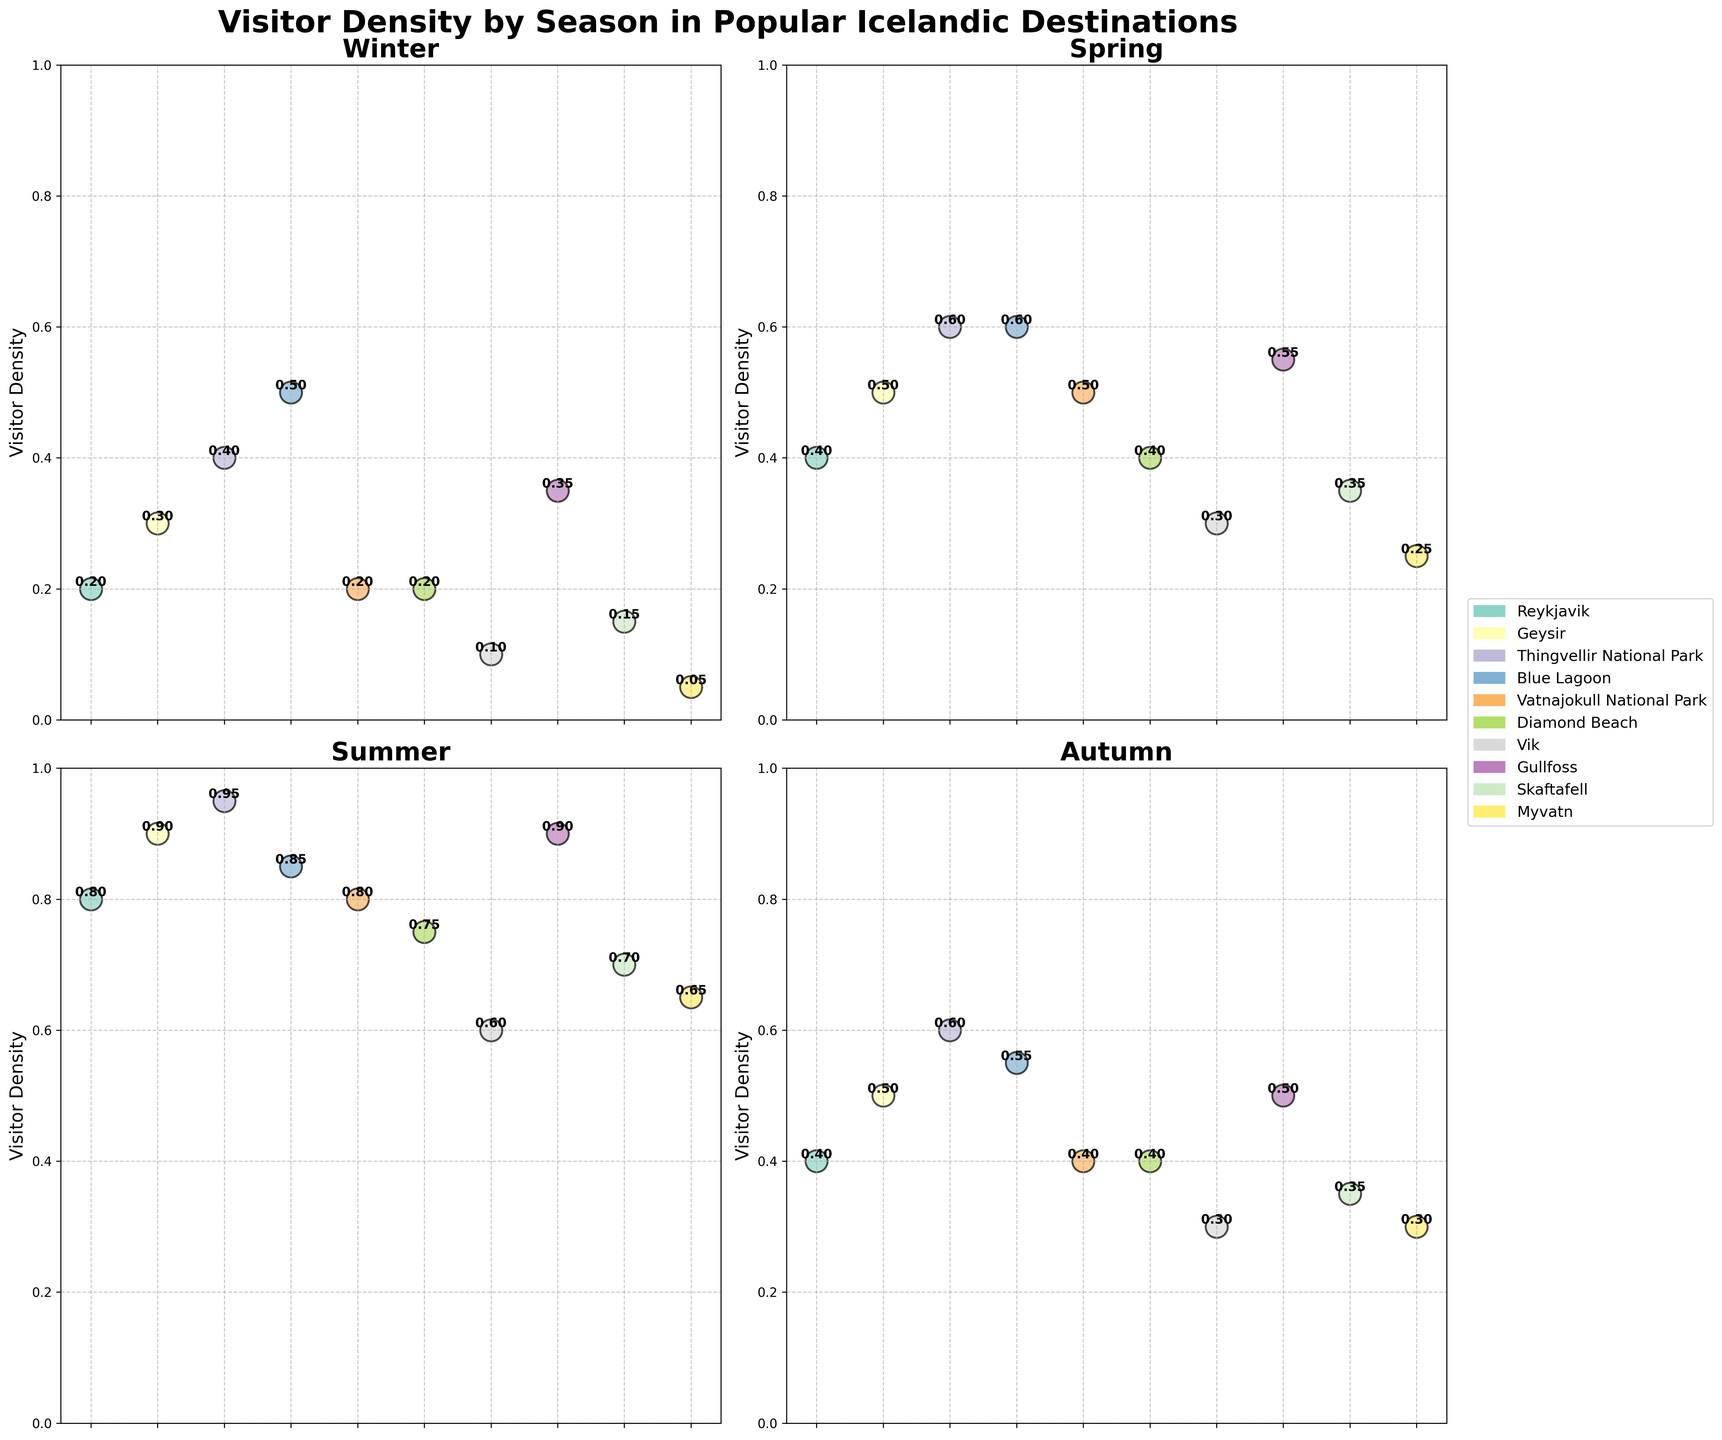What is the visitor density in Reykjavik during the summer? First, locate the subplot for summer. Within that subplot, look for the dot representing Reykjavik and read the visitor density value labeled next to it.
Answer: 0.8 Which season has the highest visitor density at Thingvellir National Park? Inspect each subplot for Thingvellir National Park and note the visitor densities. Compare the values and identify the highest one.
Answer: Summer How does the visitor density of the Blue Lagoon in winter compare to its density in autumn? Locate the dots for the Blue Lagoon in the winter and autumn subplots. Read the visitor density values and compare them.
Answer: Winter: 0.5, Autumn: 0.55; Winter is slightly lower than autumn What are the top three destinations with the highest visitor density in spring? Look at the spring subplot and identify the three dots with the highest values next to them.
Answer: Thingvellir National Park, Blue Lagoon, Gullfoss Which destination shows the greatest seasonal change in visitor density? Identify the dots representing each destination across all seasons. Calculate the difference between the highest and lowest visitor densities for each destination and compare them to find the greatest change.
Answer: Thingvellir National Park (0.95 in summer and 0.4 in winter, change = 0.55) What is the overall trend in visitor density at Gullfoss across the four seasons? Locate the dots for Gullfoss in each subplot and note the visitor density values. Observe the pattern or trend from winter to autumn.
Answer: Increases from winter to summer, then decreases in autumn Is there any destination with the same visitor density in two different seasons? Check if any destinations have equal visitor densities in more than one subplot by comparing values across all seasons.
Answer: Reykjavik (0.4 in both spring and autumn) 